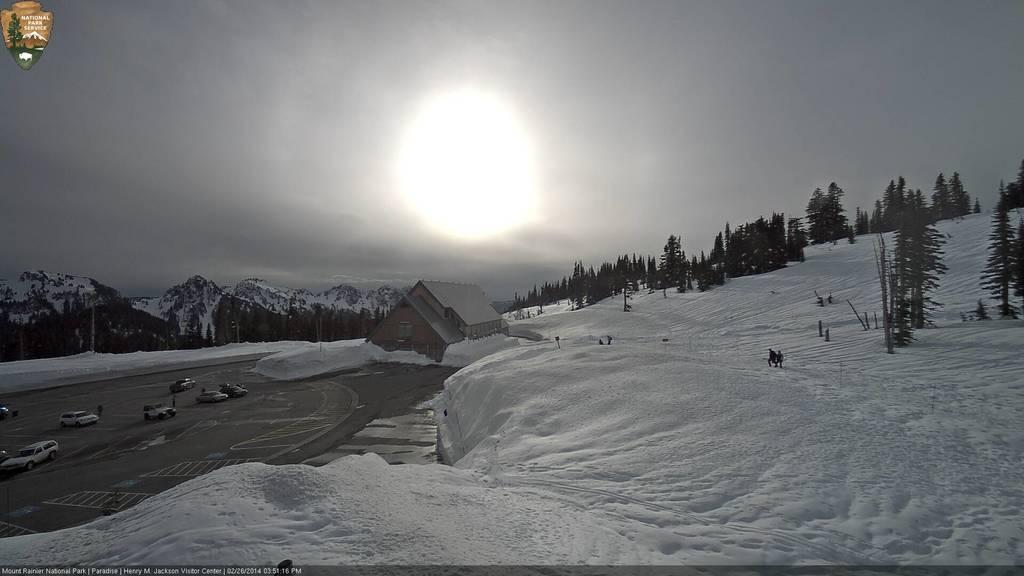How would you summarize this image in a sentence or two? In the picture we can see a snow hill which is covered with trees and few persons are walking on it and near to it, we can see a house and around it also we can see a snow and near it, we can see a road surface with some vehicles and some people standing near to it, and in the background we can see some mountains with a snow on it and behind it we can see a sky with a sun. 